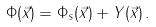<formula> <loc_0><loc_0><loc_500><loc_500>\Phi ( { \vec { x } } ) = \Phi _ { s } ( { \vec { x } } ) + Y ( { \vec { x } } ) \, .</formula> 